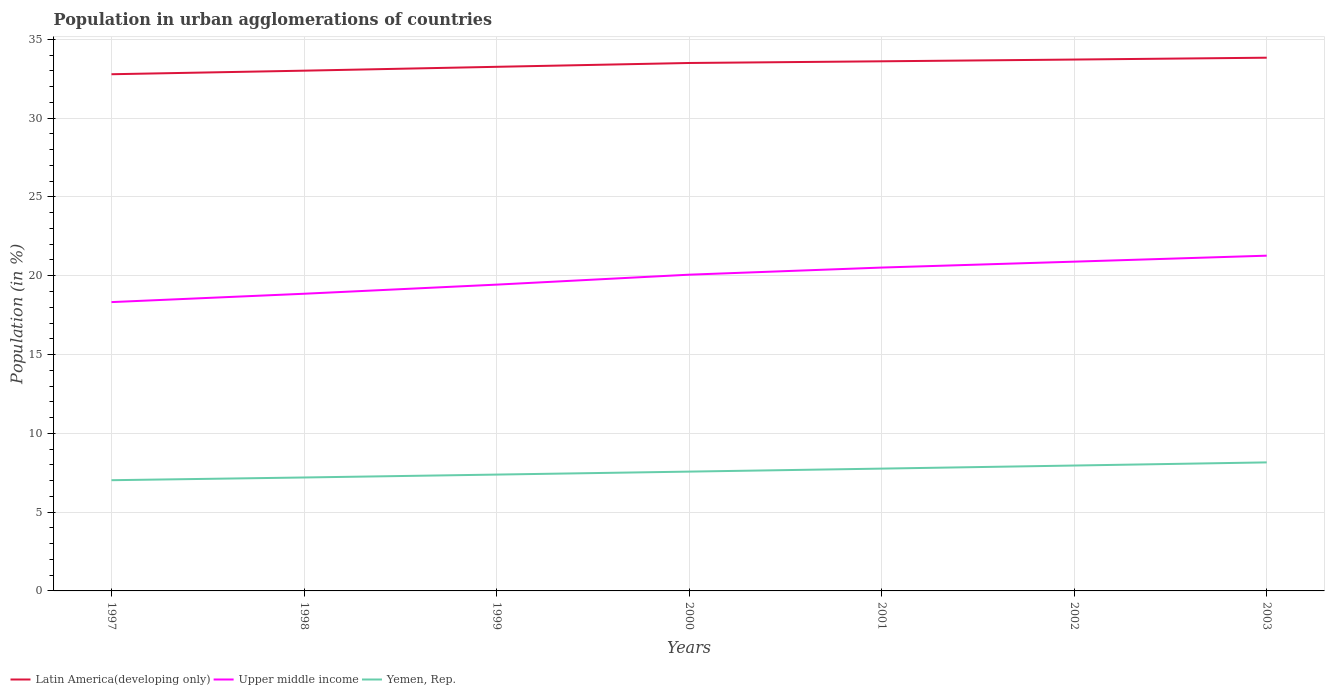How many different coloured lines are there?
Give a very brief answer. 3. Is the number of lines equal to the number of legend labels?
Provide a short and direct response. Yes. Across all years, what is the maximum percentage of population in urban agglomerations in Upper middle income?
Offer a very short reply. 18.33. In which year was the percentage of population in urban agglomerations in Upper middle income maximum?
Your answer should be very brief. 1997. What is the total percentage of population in urban agglomerations in Upper middle income in the graph?
Your answer should be compact. -0.83. What is the difference between the highest and the second highest percentage of population in urban agglomerations in Latin America(developing only)?
Provide a succinct answer. 1.05. Is the percentage of population in urban agglomerations in Yemen, Rep. strictly greater than the percentage of population in urban agglomerations in Latin America(developing only) over the years?
Your response must be concise. Yes. How many lines are there?
Your answer should be compact. 3. How many years are there in the graph?
Provide a succinct answer. 7. Does the graph contain any zero values?
Keep it short and to the point. No. Does the graph contain grids?
Keep it short and to the point. Yes. Where does the legend appear in the graph?
Your response must be concise. Bottom left. How many legend labels are there?
Your response must be concise. 3. How are the legend labels stacked?
Your response must be concise. Horizontal. What is the title of the graph?
Ensure brevity in your answer.  Population in urban agglomerations of countries. What is the label or title of the X-axis?
Provide a short and direct response. Years. What is the label or title of the Y-axis?
Give a very brief answer. Population (in %). What is the Population (in %) in Latin America(developing only) in 1997?
Ensure brevity in your answer.  32.79. What is the Population (in %) in Upper middle income in 1997?
Your response must be concise. 18.33. What is the Population (in %) of Yemen, Rep. in 1997?
Your response must be concise. 7.03. What is the Population (in %) of Latin America(developing only) in 1998?
Offer a very short reply. 33.01. What is the Population (in %) in Upper middle income in 1998?
Give a very brief answer. 18.86. What is the Population (in %) of Yemen, Rep. in 1998?
Ensure brevity in your answer.  7.2. What is the Population (in %) of Latin America(developing only) in 1999?
Your answer should be compact. 33.26. What is the Population (in %) in Upper middle income in 1999?
Your answer should be very brief. 19.44. What is the Population (in %) in Yemen, Rep. in 1999?
Your answer should be compact. 7.38. What is the Population (in %) of Latin America(developing only) in 2000?
Provide a short and direct response. 33.5. What is the Population (in %) of Upper middle income in 2000?
Your answer should be compact. 20.07. What is the Population (in %) of Yemen, Rep. in 2000?
Ensure brevity in your answer.  7.57. What is the Population (in %) of Latin America(developing only) in 2001?
Ensure brevity in your answer.  33.61. What is the Population (in %) of Upper middle income in 2001?
Your answer should be very brief. 20.52. What is the Population (in %) in Yemen, Rep. in 2001?
Offer a terse response. 7.76. What is the Population (in %) in Latin America(developing only) in 2002?
Give a very brief answer. 33.72. What is the Population (in %) in Upper middle income in 2002?
Your answer should be very brief. 20.89. What is the Population (in %) of Yemen, Rep. in 2002?
Ensure brevity in your answer.  7.96. What is the Population (in %) in Latin America(developing only) in 2003?
Your response must be concise. 33.83. What is the Population (in %) of Upper middle income in 2003?
Your answer should be very brief. 21.27. What is the Population (in %) of Yemen, Rep. in 2003?
Make the answer very short. 8.16. Across all years, what is the maximum Population (in %) in Latin America(developing only)?
Provide a succinct answer. 33.83. Across all years, what is the maximum Population (in %) in Upper middle income?
Keep it short and to the point. 21.27. Across all years, what is the maximum Population (in %) in Yemen, Rep.?
Give a very brief answer. 8.16. Across all years, what is the minimum Population (in %) in Latin America(developing only)?
Provide a succinct answer. 32.79. Across all years, what is the minimum Population (in %) of Upper middle income?
Provide a short and direct response. 18.33. Across all years, what is the minimum Population (in %) in Yemen, Rep.?
Your response must be concise. 7.03. What is the total Population (in %) of Latin America(developing only) in the graph?
Keep it short and to the point. 233.71. What is the total Population (in %) in Upper middle income in the graph?
Give a very brief answer. 139.37. What is the total Population (in %) in Yemen, Rep. in the graph?
Provide a succinct answer. 53.05. What is the difference between the Population (in %) of Latin America(developing only) in 1997 and that in 1998?
Make the answer very short. -0.23. What is the difference between the Population (in %) of Upper middle income in 1997 and that in 1998?
Provide a succinct answer. -0.53. What is the difference between the Population (in %) in Yemen, Rep. in 1997 and that in 1998?
Provide a short and direct response. -0.17. What is the difference between the Population (in %) of Latin America(developing only) in 1997 and that in 1999?
Provide a short and direct response. -0.47. What is the difference between the Population (in %) in Upper middle income in 1997 and that in 1999?
Provide a short and direct response. -1.11. What is the difference between the Population (in %) in Yemen, Rep. in 1997 and that in 1999?
Offer a very short reply. -0.36. What is the difference between the Population (in %) of Latin America(developing only) in 1997 and that in 2000?
Provide a short and direct response. -0.71. What is the difference between the Population (in %) of Upper middle income in 1997 and that in 2000?
Give a very brief answer. -1.74. What is the difference between the Population (in %) of Yemen, Rep. in 1997 and that in 2000?
Offer a very short reply. -0.55. What is the difference between the Population (in %) of Latin America(developing only) in 1997 and that in 2001?
Your answer should be compact. -0.82. What is the difference between the Population (in %) in Upper middle income in 1997 and that in 2001?
Your answer should be compact. -2.19. What is the difference between the Population (in %) in Yemen, Rep. in 1997 and that in 2001?
Your response must be concise. -0.74. What is the difference between the Population (in %) of Latin America(developing only) in 1997 and that in 2002?
Ensure brevity in your answer.  -0.93. What is the difference between the Population (in %) in Upper middle income in 1997 and that in 2002?
Ensure brevity in your answer.  -2.57. What is the difference between the Population (in %) in Yemen, Rep. in 1997 and that in 2002?
Make the answer very short. -0.93. What is the difference between the Population (in %) in Latin America(developing only) in 1997 and that in 2003?
Your response must be concise. -1.05. What is the difference between the Population (in %) of Upper middle income in 1997 and that in 2003?
Your answer should be very brief. -2.95. What is the difference between the Population (in %) in Yemen, Rep. in 1997 and that in 2003?
Provide a short and direct response. -1.13. What is the difference between the Population (in %) of Latin America(developing only) in 1998 and that in 1999?
Make the answer very short. -0.24. What is the difference between the Population (in %) of Upper middle income in 1998 and that in 1999?
Provide a short and direct response. -0.58. What is the difference between the Population (in %) in Yemen, Rep. in 1998 and that in 1999?
Offer a terse response. -0.18. What is the difference between the Population (in %) of Latin America(developing only) in 1998 and that in 2000?
Make the answer very short. -0.49. What is the difference between the Population (in %) of Upper middle income in 1998 and that in 2000?
Your answer should be very brief. -1.21. What is the difference between the Population (in %) in Yemen, Rep. in 1998 and that in 2000?
Ensure brevity in your answer.  -0.37. What is the difference between the Population (in %) of Latin America(developing only) in 1998 and that in 2001?
Keep it short and to the point. -0.59. What is the difference between the Population (in %) of Upper middle income in 1998 and that in 2001?
Your answer should be compact. -1.66. What is the difference between the Population (in %) in Yemen, Rep. in 1998 and that in 2001?
Offer a terse response. -0.56. What is the difference between the Population (in %) of Latin America(developing only) in 1998 and that in 2002?
Offer a very short reply. -0.71. What is the difference between the Population (in %) in Upper middle income in 1998 and that in 2002?
Provide a short and direct response. -2.04. What is the difference between the Population (in %) in Yemen, Rep. in 1998 and that in 2002?
Ensure brevity in your answer.  -0.76. What is the difference between the Population (in %) of Latin America(developing only) in 1998 and that in 2003?
Provide a short and direct response. -0.82. What is the difference between the Population (in %) of Upper middle income in 1998 and that in 2003?
Your response must be concise. -2.42. What is the difference between the Population (in %) in Yemen, Rep. in 1998 and that in 2003?
Your response must be concise. -0.96. What is the difference between the Population (in %) in Latin America(developing only) in 1999 and that in 2000?
Provide a short and direct response. -0.24. What is the difference between the Population (in %) of Upper middle income in 1999 and that in 2000?
Your answer should be compact. -0.63. What is the difference between the Population (in %) of Yemen, Rep. in 1999 and that in 2000?
Your response must be concise. -0.19. What is the difference between the Population (in %) of Latin America(developing only) in 1999 and that in 2001?
Offer a terse response. -0.35. What is the difference between the Population (in %) of Upper middle income in 1999 and that in 2001?
Keep it short and to the point. -1.08. What is the difference between the Population (in %) in Yemen, Rep. in 1999 and that in 2001?
Give a very brief answer. -0.38. What is the difference between the Population (in %) in Latin America(developing only) in 1999 and that in 2002?
Make the answer very short. -0.46. What is the difference between the Population (in %) of Upper middle income in 1999 and that in 2002?
Your answer should be very brief. -1.46. What is the difference between the Population (in %) of Yemen, Rep. in 1999 and that in 2002?
Your answer should be compact. -0.57. What is the difference between the Population (in %) of Latin America(developing only) in 1999 and that in 2003?
Offer a very short reply. -0.58. What is the difference between the Population (in %) of Upper middle income in 1999 and that in 2003?
Ensure brevity in your answer.  -1.84. What is the difference between the Population (in %) of Yemen, Rep. in 1999 and that in 2003?
Offer a terse response. -0.77. What is the difference between the Population (in %) in Latin America(developing only) in 2000 and that in 2001?
Offer a terse response. -0.11. What is the difference between the Population (in %) of Upper middle income in 2000 and that in 2001?
Offer a terse response. -0.45. What is the difference between the Population (in %) of Yemen, Rep. in 2000 and that in 2001?
Give a very brief answer. -0.19. What is the difference between the Population (in %) of Latin America(developing only) in 2000 and that in 2002?
Offer a terse response. -0.22. What is the difference between the Population (in %) in Upper middle income in 2000 and that in 2002?
Keep it short and to the point. -0.83. What is the difference between the Population (in %) in Yemen, Rep. in 2000 and that in 2002?
Make the answer very short. -0.38. What is the difference between the Population (in %) in Latin America(developing only) in 2000 and that in 2003?
Offer a terse response. -0.34. What is the difference between the Population (in %) in Upper middle income in 2000 and that in 2003?
Keep it short and to the point. -1.21. What is the difference between the Population (in %) of Yemen, Rep. in 2000 and that in 2003?
Give a very brief answer. -0.58. What is the difference between the Population (in %) of Latin America(developing only) in 2001 and that in 2002?
Give a very brief answer. -0.11. What is the difference between the Population (in %) of Upper middle income in 2001 and that in 2002?
Keep it short and to the point. -0.38. What is the difference between the Population (in %) in Yemen, Rep. in 2001 and that in 2002?
Offer a terse response. -0.2. What is the difference between the Population (in %) of Latin America(developing only) in 2001 and that in 2003?
Offer a very short reply. -0.23. What is the difference between the Population (in %) in Upper middle income in 2001 and that in 2003?
Keep it short and to the point. -0.76. What is the difference between the Population (in %) of Yemen, Rep. in 2001 and that in 2003?
Your answer should be very brief. -0.39. What is the difference between the Population (in %) of Latin America(developing only) in 2002 and that in 2003?
Keep it short and to the point. -0.12. What is the difference between the Population (in %) of Upper middle income in 2002 and that in 2003?
Give a very brief answer. -0.38. What is the difference between the Population (in %) of Yemen, Rep. in 2002 and that in 2003?
Provide a succinct answer. -0.2. What is the difference between the Population (in %) in Latin America(developing only) in 1997 and the Population (in %) in Upper middle income in 1998?
Give a very brief answer. 13.93. What is the difference between the Population (in %) in Latin America(developing only) in 1997 and the Population (in %) in Yemen, Rep. in 1998?
Give a very brief answer. 25.59. What is the difference between the Population (in %) of Upper middle income in 1997 and the Population (in %) of Yemen, Rep. in 1998?
Make the answer very short. 11.13. What is the difference between the Population (in %) in Latin America(developing only) in 1997 and the Population (in %) in Upper middle income in 1999?
Your answer should be compact. 13.35. What is the difference between the Population (in %) in Latin America(developing only) in 1997 and the Population (in %) in Yemen, Rep. in 1999?
Offer a very short reply. 25.4. What is the difference between the Population (in %) of Upper middle income in 1997 and the Population (in %) of Yemen, Rep. in 1999?
Keep it short and to the point. 10.94. What is the difference between the Population (in %) in Latin America(developing only) in 1997 and the Population (in %) in Upper middle income in 2000?
Ensure brevity in your answer.  12.72. What is the difference between the Population (in %) in Latin America(developing only) in 1997 and the Population (in %) in Yemen, Rep. in 2000?
Provide a succinct answer. 25.21. What is the difference between the Population (in %) in Upper middle income in 1997 and the Population (in %) in Yemen, Rep. in 2000?
Provide a short and direct response. 10.76. What is the difference between the Population (in %) of Latin America(developing only) in 1997 and the Population (in %) of Upper middle income in 2001?
Provide a succinct answer. 12.27. What is the difference between the Population (in %) of Latin America(developing only) in 1997 and the Population (in %) of Yemen, Rep. in 2001?
Ensure brevity in your answer.  25.02. What is the difference between the Population (in %) of Upper middle income in 1997 and the Population (in %) of Yemen, Rep. in 2001?
Your answer should be very brief. 10.57. What is the difference between the Population (in %) of Latin America(developing only) in 1997 and the Population (in %) of Upper middle income in 2002?
Offer a very short reply. 11.89. What is the difference between the Population (in %) of Latin America(developing only) in 1997 and the Population (in %) of Yemen, Rep. in 2002?
Your response must be concise. 24.83. What is the difference between the Population (in %) of Upper middle income in 1997 and the Population (in %) of Yemen, Rep. in 2002?
Provide a succinct answer. 10.37. What is the difference between the Population (in %) in Latin America(developing only) in 1997 and the Population (in %) in Upper middle income in 2003?
Offer a very short reply. 11.51. What is the difference between the Population (in %) in Latin America(developing only) in 1997 and the Population (in %) in Yemen, Rep. in 2003?
Your response must be concise. 24.63. What is the difference between the Population (in %) in Upper middle income in 1997 and the Population (in %) in Yemen, Rep. in 2003?
Keep it short and to the point. 10.17. What is the difference between the Population (in %) of Latin America(developing only) in 1998 and the Population (in %) of Upper middle income in 1999?
Provide a short and direct response. 13.58. What is the difference between the Population (in %) in Latin America(developing only) in 1998 and the Population (in %) in Yemen, Rep. in 1999?
Make the answer very short. 25.63. What is the difference between the Population (in %) in Upper middle income in 1998 and the Population (in %) in Yemen, Rep. in 1999?
Provide a succinct answer. 11.47. What is the difference between the Population (in %) in Latin America(developing only) in 1998 and the Population (in %) in Upper middle income in 2000?
Offer a terse response. 12.94. What is the difference between the Population (in %) in Latin America(developing only) in 1998 and the Population (in %) in Yemen, Rep. in 2000?
Keep it short and to the point. 25.44. What is the difference between the Population (in %) in Upper middle income in 1998 and the Population (in %) in Yemen, Rep. in 2000?
Keep it short and to the point. 11.28. What is the difference between the Population (in %) of Latin America(developing only) in 1998 and the Population (in %) of Upper middle income in 2001?
Ensure brevity in your answer.  12.49. What is the difference between the Population (in %) in Latin America(developing only) in 1998 and the Population (in %) in Yemen, Rep. in 2001?
Offer a very short reply. 25.25. What is the difference between the Population (in %) of Upper middle income in 1998 and the Population (in %) of Yemen, Rep. in 2001?
Offer a terse response. 11.1. What is the difference between the Population (in %) in Latin America(developing only) in 1998 and the Population (in %) in Upper middle income in 2002?
Keep it short and to the point. 12.12. What is the difference between the Population (in %) of Latin America(developing only) in 1998 and the Population (in %) of Yemen, Rep. in 2002?
Give a very brief answer. 25.06. What is the difference between the Population (in %) in Upper middle income in 1998 and the Population (in %) in Yemen, Rep. in 2002?
Your answer should be very brief. 10.9. What is the difference between the Population (in %) of Latin America(developing only) in 1998 and the Population (in %) of Upper middle income in 2003?
Give a very brief answer. 11.74. What is the difference between the Population (in %) of Latin America(developing only) in 1998 and the Population (in %) of Yemen, Rep. in 2003?
Ensure brevity in your answer.  24.86. What is the difference between the Population (in %) in Upper middle income in 1998 and the Population (in %) in Yemen, Rep. in 2003?
Provide a short and direct response. 10.7. What is the difference between the Population (in %) in Latin America(developing only) in 1999 and the Population (in %) in Upper middle income in 2000?
Your answer should be compact. 13.19. What is the difference between the Population (in %) in Latin America(developing only) in 1999 and the Population (in %) in Yemen, Rep. in 2000?
Keep it short and to the point. 25.68. What is the difference between the Population (in %) in Upper middle income in 1999 and the Population (in %) in Yemen, Rep. in 2000?
Provide a short and direct response. 11.86. What is the difference between the Population (in %) in Latin America(developing only) in 1999 and the Population (in %) in Upper middle income in 2001?
Your answer should be very brief. 12.74. What is the difference between the Population (in %) in Latin America(developing only) in 1999 and the Population (in %) in Yemen, Rep. in 2001?
Offer a very short reply. 25.5. What is the difference between the Population (in %) of Upper middle income in 1999 and the Population (in %) of Yemen, Rep. in 2001?
Ensure brevity in your answer.  11.67. What is the difference between the Population (in %) of Latin America(developing only) in 1999 and the Population (in %) of Upper middle income in 2002?
Give a very brief answer. 12.36. What is the difference between the Population (in %) of Latin America(developing only) in 1999 and the Population (in %) of Yemen, Rep. in 2002?
Offer a very short reply. 25.3. What is the difference between the Population (in %) in Upper middle income in 1999 and the Population (in %) in Yemen, Rep. in 2002?
Your answer should be very brief. 11.48. What is the difference between the Population (in %) in Latin America(developing only) in 1999 and the Population (in %) in Upper middle income in 2003?
Give a very brief answer. 11.98. What is the difference between the Population (in %) of Latin America(developing only) in 1999 and the Population (in %) of Yemen, Rep. in 2003?
Offer a terse response. 25.1. What is the difference between the Population (in %) in Upper middle income in 1999 and the Population (in %) in Yemen, Rep. in 2003?
Ensure brevity in your answer.  11.28. What is the difference between the Population (in %) of Latin America(developing only) in 2000 and the Population (in %) of Upper middle income in 2001?
Offer a very short reply. 12.98. What is the difference between the Population (in %) of Latin America(developing only) in 2000 and the Population (in %) of Yemen, Rep. in 2001?
Make the answer very short. 25.74. What is the difference between the Population (in %) of Upper middle income in 2000 and the Population (in %) of Yemen, Rep. in 2001?
Your response must be concise. 12.31. What is the difference between the Population (in %) in Latin America(developing only) in 2000 and the Population (in %) in Upper middle income in 2002?
Offer a very short reply. 12.61. What is the difference between the Population (in %) in Latin America(developing only) in 2000 and the Population (in %) in Yemen, Rep. in 2002?
Give a very brief answer. 25.54. What is the difference between the Population (in %) of Upper middle income in 2000 and the Population (in %) of Yemen, Rep. in 2002?
Give a very brief answer. 12.11. What is the difference between the Population (in %) in Latin America(developing only) in 2000 and the Population (in %) in Upper middle income in 2003?
Your answer should be very brief. 12.23. What is the difference between the Population (in %) in Latin America(developing only) in 2000 and the Population (in %) in Yemen, Rep. in 2003?
Provide a succinct answer. 25.34. What is the difference between the Population (in %) of Upper middle income in 2000 and the Population (in %) of Yemen, Rep. in 2003?
Provide a succinct answer. 11.91. What is the difference between the Population (in %) in Latin America(developing only) in 2001 and the Population (in %) in Upper middle income in 2002?
Give a very brief answer. 12.71. What is the difference between the Population (in %) of Latin America(developing only) in 2001 and the Population (in %) of Yemen, Rep. in 2002?
Offer a terse response. 25.65. What is the difference between the Population (in %) of Upper middle income in 2001 and the Population (in %) of Yemen, Rep. in 2002?
Offer a very short reply. 12.56. What is the difference between the Population (in %) of Latin America(developing only) in 2001 and the Population (in %) of Upper middle income in 2003?
Offer a terse response. 12.33. What is the difference between the Population (in %) of Latin America(developing only) in 2001 and the Population (in %) of Yemen, Rep. in 2003?
Your answer should be very brief. 25.45. What is the difference between the Population (in %) in Upper middle income in 2001 and the Population (in %) in Yemen, Rep. in 2003?
Provide a short and direct response. 12.36. What is the difference between the Population (in %) in Latin America(developing only) in 2002 and the Population (in %) in Upper middle income in 2003?
Make the answer very short. 12.44. What is the difference between the Population (in %) of Latin America(developing only) in 2002 and the Population (in %) of Yemen, Rep. in 2003?
Your answer should be compact. 25.56. What is the difference between the Population (in %) of Upper middle income in 2002 and the Population (in %) of Yemen, Rep. in 2003?
Keep it short and to the point. 12.74. What is the average Population (in %) in Latin America(developing only) per year?
Your answer should be compact. 33.39. What is the average Population (in %) of Upper middle income per year?
Offer a very short reply. 19.91. What is the average Population (in %) in Yemen, Rep. per year?
Your answer should be very brief. 7.58. In the year 1997, what is the difference between the Population (in %) in Latin America(developing only) and Population (in %) in Upper middle income?
Keep it short and to the point. 14.46. In the year 1997, what is the difference between the Population (in %) in Latin America(developing only) and Population (in %) in Yemen, Rep.?
Make the answer very short. 25.76. In the year 1997, what is the difference between the Population (in %) of Upper middle income and Population (in %) of Yemen, Rep.?
Provide a short and direct response. 11.3. In the year 1998, what is the difference between the Population (in %) of Latin America(developing only) and Population (in %) of Upper middle income?
Your answer should be compact. 14.16. In the year 1998, what is the difference between the Population (in %) in Latin America(developing only) and Population (in %) in Yemen, Rep.?
Keep it short and to the point. 25.81. In the year 1998, what is the difference between the Population (in %) of Upper middle income and Population (in %) of Yemen, Rep.?
Keep it short and to the point. 11.66. In the year 1999, what is the difference between the Population (in %) of Latin America(developing only) and Population (in %) of Upper middle income?
Provide a short and direct response. 13.82. In the year 1999, what is the difference between the Population (in %) in Latin America(developing only) and Population (in %) in Yemen, Rep.?
Provide a short and direct response. 25.87. In the year 1999, what is the difference between the Population (in %) in Upper middle income and Population (in %) in Yemen, Rep.?
Provide a short and direct response. 12.05. In the year 2000, what is the difference between the Population (in %) in Latin America(developing only) and Population (in %) in Upper middle income?
Keep it short and to the point. 13.43. In the year 2000, what is the difference between the Population (in %) in Latin America(developing only) and Population (in %) in Yemen, Rep.?
Your answer should be compact. 25.93. In the year 2000, what is the difference between the Population (in %) of Upper middle income and Population (in %) of Yemen, Rep.?
Your answer should be very brief. 12.5. In the year 2001, what is the difference between the Population (in %) of Latin America(developing only) and Population (in %) of Upper middle income?
Your answer should be very brief. 13.09. In the year 2001, what is the difference between the Population (in %) of Latin America(developing only) and Population (in %) of Yemen, Rep.?
Offer a very short reply. 25.84. In the year 2001, what is the difference between the Population (in %) of Upper middle income and Population (in %) of Yemen, Rep.?
Give a very brief answer. 12.76. In the year 2002, what is the difference between the Population (in %) of Latin America(developing only) and Population (in %) of Upper middle income?
Your answer should be very brief. 12.82. In the year 2002, what is the difference between the Population (in %) of Latin America(developing only) and Population (in %) of Yemen, Rep.?
Provide a short and direct response. 25.76. In the year 2002, what is the difference between the Population (in %) in Upper middle income and Population (in %) in Yemen, Rep.?
Your answer should be compact. 12.94. In the year 2003, what is the difference between the Population (in %) in Latin America(developing only) and Population (in %) in Upper middle income?
Ensure brevity in your answer.  12.56. In the year 2003, what is the difference between the Population (in %) in Latin America(developing only) and Population (in %) in Yemen, Rep.?
Offer a terse response. 25.68. In the year 2003, what is the difference between the Population (in %) of Upper middle income and Population (in %) of Yemen, Rep.?
Offer a terse response. 13.12. What is the ratio of the Population (in %) of Upper middle income in 1997 to that in 1998?
Keep it short and to the point. 0.97. What is the ratio of the Population (in %) of Yemen, Rep. in 1997 to that in 1998?
Keep it short and to the point. 0.98. What is the ratio of the Population (in %) of Latin America(developing only) in 1997 to that in 1999?
Ensure brevity in your answer.  0.99. What is the ratio of the Population (in %) of Upper middle income in 1997 to that in 1999?
Your response must be concise. 0.94. What is the ratio of the Population (in %) in Yemen, Rep. in 1997 to that in 1999?
Keep it short and to the point. 0.95. What is the ratio of the Population (in %) in Latin America(developing only) in 1997 to that in 2000?
Keep it short and to the point. 0.98. What is the ratio of the Population (in %) in Upper middle income in 1997 to that in 2000?
Your answer should be very brief. 0.91. What is the ratio of the Population (in %) of Yemen, Rep. in 1997 to that in 2000?
Offer a very short reply. 0.93. What is the ratio of the Population (in %) in Latin America(developing only) in 1997 to that in 2001?
Give a very brief answer. 0.98. What is the ratio of the Population (in %) of Upper middle income in 1997 to that in 2001?
Give a very brief answer. 0.89. What is the ratio of the Population (in %) in Yemen, Rep. in 1997 to that in 2001?
Offer a very short reply. 0.91. What is the ratio of the Population (in %) in Latin America(developing only) in 1997 to that in 2002?
Ensure brevity in your answer.  0.97. What is the ratio of the Population (in %) of Upper middle income in 1997 to that in 2002?
Your answer should be compact. 0.88. What is the ratio of the Population (in %) in Yemen, Rep. in 1997 to that in 2002?
Your answer should be compact. 0.88. What is the ratio of the Population (in %) of Upper middle income in 1997 to that in 2003?
Provide a short and direct response. 0.86. What is the ratio of the Population (in %) of Yemen, Rep. in 1997 to that in 2003?
Your response must be concise. 0.86. What is the ratio of the Population (in %) in Upper middle income in 1998 to that in 1999?
Provide a succinct answer. 0.97. What is the ratio of the Population (in %) of Latin America(developing only) in 1998 to that in 2000?
Your response must be concise. 0.99. What is the ratio of the Population (in %) of Upper middle income in 1998 to that in 2000?
Provide a succinct answer. 0.94. What is the ratio of the Population (in %) in Yemen, Rep. in 1998 to that in 2000?
Your response must be concise. 0.95. What is the ratio of the Population (in %) of Latin America(developing only) in 1998 to that in 2001?
Offer a very short reply. 0.98. What is the ratio of the Population (in %) in Upper middle income in 1998 to that in 2001?
Offer a terse response. 0.92. What is the ratio of the Population (in %) in Yemen, Rep. in 1998 to that in 2001?
Provide a succinct answer. 0.93. What is the ratio of the Population (in %) in Upper middle income in 1998 to that in 2002?
Your response must be concise. 0.9. What is the ratio of the Population (in %) in Yemen, Rep. in 1998 to that in 2002?
Your answer should be compact. 0.9. What is the ratio of the Population (in %) of Latin America(developing only) in 1998 to that in 2003?
Give a very brief answer. 0.98. What is the ratio of the Population (in %) in Upper middle income in 1998 to that in 2003?
Offer a very short reply. 0.89. What is the ratio of the Population (in %) of Yemen, Rep. in 1998 to that in 2003?
Offer a very short reply. 0.88. What is the ratio of the Population (in %) of Latin America(developing only) in 1999 to that in 2000?
Provide a succinct answer. 0.99. What is the ratio of the Population (in %) in Upper middle income in 1999 to that in 2000?
Your answer should be compact. 0.97. What is the ratio of the Population (in %) in Yemen, Rep. in 1999 to that in 2000?
Your response must be concise. 0.98. What is the ratio of the Population (in %) of Latin America(developing only) in 1999 to that in 2001?
Ensure brevity in your answer.  0.99. What is the ratio of the Population (in %) of Upper middle income in 1999 to that in 2001?
Your answer should be very brief. 0.95. What is the ratio of the Population (in %) of Yemen, Rep. in 1999 to that in 2001?
Ensure brevity in your answer.  0.95. What is the ratio of the Population (in %) in Latin America(developing only) in 1999 to that in 2002?
Ensure brevity in your answer.  0.99. What is the ratio of the Population (in %) of Upper middle income in 1999 to that in 2002?
Offer a terse response. 0.93. What is the ratio of the Population (in %) in Yemen, Rep. in 1999 to that in 2002?
Offer a terse response. 0.93. What is the ratio of the Population (in %) of Latin America(developing only) in 1999 to that in 2003?
Give a very brief answer. 0.98. What is the ratio of the Population (in %) of Upper middle income in 1999 to that in 2003?
Give a very brief answer. 0.91. What is the ratio of the Population (in %) in Yemen, Rep. in 1999 to that in 2003?
Offer a very short reply. 0.91. What is the ratio of the Population (in %) of Latin America(developing only) in 2000 to that in 2001?
Your answer should be compact. 1. What is the ratio of the Population (in %) of Yemen, Rep. in 2000 to that in 2001?
Your answer should be compact. 0.98. What is the ratio of the Population (in %) of Latin America(developing only) in 2000 to that in 2002?
Offer a very short reply. 0.99. What is the ratio of the Population (in %) in Upper middle income in 2000 to that in 2002?
Make the answer very short. 0.96. What is the ratio of the Population (in %) in Yemen, Rep. in 2000 to that in 2002?
Provide a succinct answer. 0.95. What is the ratio of the Population (in %) of Latin America(developing only) in 2000 to that in 2003?
Your response must be concise. 0.99. What is the ratio of the Population (in %) in Upper middle income in 2000 to that in 2003?
Offer a terse response. 0.94. What is the ratio of the Population (in %) in Yemen, Rep. in 2000 to that in 2003?
Provide a short and direct response. 0.93. What is the ratio of the Population (in %) of Latin America(developing only) in 2001 to that in 2002?
Keep it short and to the point. 1. What is the ratio of the Population (in %) in Yemen, Rep. in 2001 to that in 2002?
Offer a terse response. 0.98. What is the ratio of the Population (in %) of Latin America(developing only) in 2001 to that in 2003?
Ensure brevity in your answer.  0.99. What is the ratio of the Population (in %) in Upper middle income in 2001 to that in 2003?
Give a very brief answer. 0.96. What is the ratio of the Population (in %) in Yemen, Rep. in 2001 to that in 2003?
Your answer should be very brief. 0.95. What is the ratio of the Population (in %) in Upper middle income in 2002 to that in 2003?
Your answer should be very brief. 0.98. What is the ratio of the Population (in %) of Yemen, Rep. in 2002 to that in 2003?
Provide a short and direct response. 0.98. What is the difference between the highest and the second highest Population (in %) in Latin America(developing only)?
Ensure brevity in your answer.  0.12. What is the difference between the highest and the second highest Population (in %) in Upper middle income?
Give a very brief answer. 0.38. What is the difference between the highest and the second highest Population (in %) in Yemen, Rep.?
Keep it short and to the point. 0.2. What is the difference between the highest and the lowest Population (in %) in Latin America(developing only)?
Offer a very short reply. 1.05. What is the difference between the highest and the lowest Population (in %) in Upper middle income?
Make the answer very short. 2.95. What is the difference between the highest and the lowest Population (in %) in Yemen, Rep.?
Your response must be concise. 1.13. 